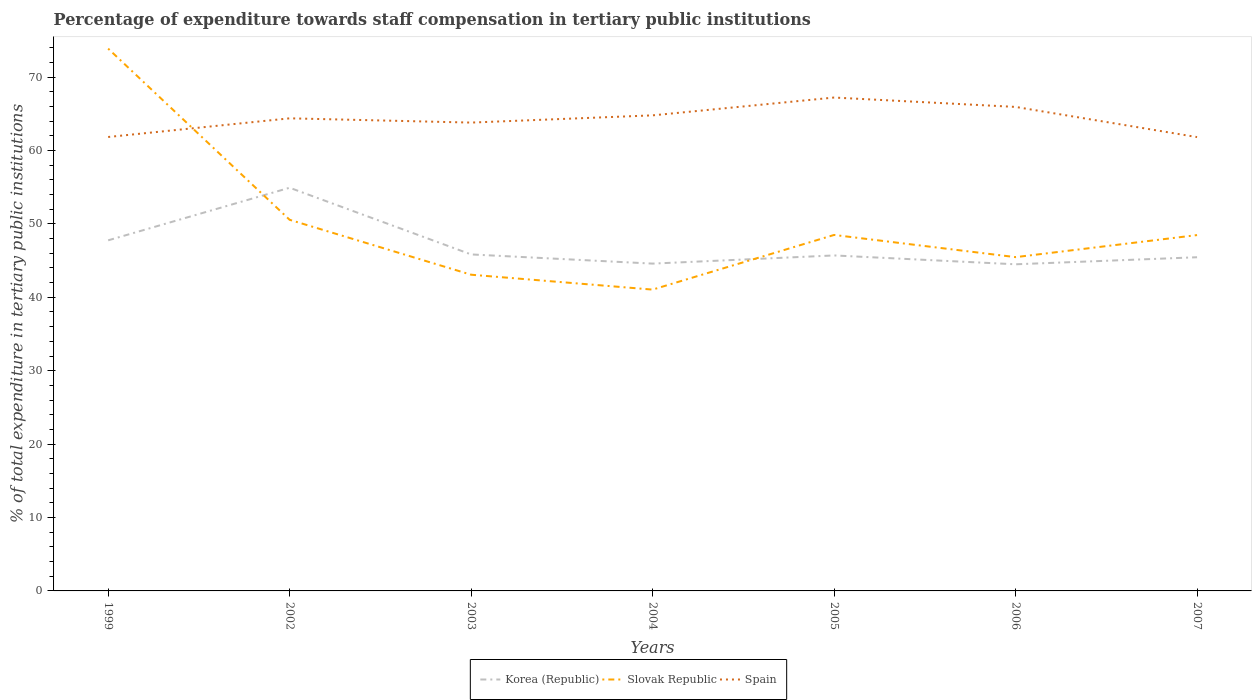How many different coloured lines are there?
Give a very brief answer. 3. Across all years, what is the maximum percentage of expenditure towards staff compensation in Korea (Republic)?
Your answer should be compact. 44.5. In which year was the percentage of expenditure towards staff compensation in Slovak Republic maximum?
Ensure brevity in your answer.  2004. What is the total percentage of expenditure towards staff compensation in Korea (Republic) in the graph?
Your answer should be compact. 10.34. What is the difference between the highest and the second highest percentage of expenditure towards staff compensation in Korea (Republic)?
Ensure brevity in your answer.  10.43. What is the difference between the highest and the lowest percentage of expenditure towards staff compensation in Spain?
Provide a short and direct response. 4. Is the percentage of expenditure towards staff compensation in Korea (Republic) strictly greater than the percentage of expenditure towards staff compensation in Slovak Republic over the years?
Offer a terse response. No. Does the graph contain any zero values?
Offer a very short reply. No. How are the legend labels stacked?
Provide a short and direct response. Horizontal. What is the title of the graph?
Your answer should be compact. Percentage of expenditure towards staff compensation in tertiary public institutions. Does "North America" appear as one of the legend labels in the graph?
Make the answer very short. No. What is the label or title of the X-axis?
Offer a very short reply. Years. What is the label or title of the Y-axis?
Your answer should be very brief. % of total expenditure in tertiary public institutions. What is the % of total expenditure in tertiary public institutions of Korea (Republic) in 1999?
Provide a succinct answer. 47.76. What is the % of total expenditure in tertiary public institutions of Slovak Republic in 1999?
Provide a succinct answer. 73.88. What is the % of total expenditure in tertiary public institutions in Spain in 1999?
Make the answer very short. 61.84. What is the % of total expenditure in tertiary public institutions in Korea (Republic) in 2002?
Your answer should be compact. 54.93. What is the % of total expenditure in tertiary public institutions in Slovak Republic in 2002?
Keep it short and to the point. 50.56. What is the % of total expenditure in tertiary public institutions in Spain in 2002?
Give a very brief answer. 64.38. What is the % of total expenditure in tertiary public institutions in Korea (Republic) in 2003?
Give a very brief answer. 45.84. What is the % of total expenditure in tertiary public institutions of Slovak Republic in 2003?
Your answer should be compact. 43.08. What is the % of total expenditure in tertiary public institutions of Spain in 2003?
Your answer should be very brief. 63.8. What is the % of total expenditure in tertiary public institutions of Korea (Republic) in 2004?
Your answer should be very brief. 44.59. What is the % of total expenditure in tertiary public institutions in Slovak Republic in 2004?
Your answer should be very brief. 41.05. What is the % of total expenditure in tertiary public institutions in Spain in 2004?
Your response must be concise. 64.79. What is the % of total expenditure in tertiary public institutions in Korea (Republic) in 2005?
Provide a succinct answer. 45.71. What is the % of total expenditure in tertiary public institutions in Slovak Republic in 2005?
Give a very brief answer. 48.5. What is the % of total expenditure in tertiary public institutions in Spain in 2005?
Offer a terse response. 67.22. What is the % of total expenditure in tertiary public institutions of Korea (Republic) in 2006?
Make the answer very short. 44.5. What is the % of total expenditure in tertiary public institutions of Slovak Republic in 2006?
Make the answer very short. 45.47. What is the % of total expenditure in tertiary public institutions in Spain in 2006?
Make the answer very short. 65.94. What is the % of total expenditure in tertiary public institutions of Korea (Republic) in 2007?
Offer a terse response. 45.46. What is the % of total expenditure in tertiary public institutions in Slovak Republic in 2007?
Your answer should be very brief. 48.48. What is the % of total expenditure in tertiary public institutions of Spain in 2007?
Offer a terse response. 61.83. Across all years, what is the maximum % of total expenditure in tertiary public institutions in Korea (Republic)?
Your response must be concise. 54.93. Across all years, what is the maximum % of total expenditure in tertiary public institutions of Slovak Republic?
Give a very brief answer. 73.88. Across all years, what is the maximum % of total expenditure in tertiary public institutions in Spain?
Provide a succinct answer. 67.22. Across all years, what is the minimum % of total expenditure in tertiary public institutions in Korea (Republic)?
Keep it short and to the point. 44.5. Across all years, what is the minimum % of total expenditure in tertiary public institutions of Slovak Republic?
Make the answer very short. 41.05. Across all years, what is the minimum % of total expenditure in tertiary public institutions in Spain?
Give a very brief answer. 61.83. What is the total % of total expenditure in tertiary public institutions of Korea (Republic) in the graph?
Your answer should be very brief. 328.79. What is the total % of total expenditure in tertiary public institutions in Slovak Republic in the graph?
Offer a terse response. 351.02. What is the total % of total expenditure in tertiary public institutions of Spain in the graph?
Your response must be concise. 449.8. What is the difference between the % of total expenditure in tertiary public institutions in Korea (Republic) in 1999 and that in 2002?
Provide a short and direct response. -7.16. What is the difference between the % of total expenditure in tertiary public institutions in Slovak Republic in 1999 and that in 2002?
Make the answer very short. 23.32. What is the difference between the % of total expenditure in tertiary public institutions of Spain in 1999 and that in 2002?
Keep it short and to the point. -2.54. What is the difference between the % of total expenditure in tertiary public institutions of Korea (Republic) in 1999 and that in 2003?
Your answer should be very brief. 1.92. What is the difference between the % of total expenditure in tertiary public institutions in Slovak Republic in 1999 and that in 2003?
Your answer should be compact. 30.8. What is the difference between the % of total expenditure in tertiary public institutions of Spain in 1999 and that in 2003?
Offer a very short reply. -1.96. What is the difference between the % of total expenditure in tertiary public institutions in Korea (Republic) in 1999 and that in 2004?
Provide a short and direct response. 3.17. What is the difference between the % of total expenditure in tertiary public institutions in Slovak Republic in 1999 and that in 2004?
Provide a succinct answer. 32.83. What is the difference between the % of total expenditure in tertiary public institutions in Spain in 1999 and that in 2004?
Your answer should be compact. -2.95. What is the difference between the % of total expenditure in tertiary public institutions of Korea (Republic) in 1999 and that in 2005?
Provide a short and direct response. 2.06. What is the difference between the % of total expenditure in tertiary public institutions of Slovak Republic in 1999 and that in 2005?
Make the answer very short. 25.39. What is the difference between the % of total expenditure in tertiary public institutions of Spain in 1999 and that in 2005?
Make the answer very short. -5.38. What is the difference between the % of total expenditure in tertiary public institutions in Korea (Republic) in 1999 and that in 2006?
Make the answer very short. 3.26. What is the difference between the % of total expenditure in tertiary public institutions of Slovak Republic in 1999 and that in 2006?
Provide a short and direct response. 28.41. What is the difference between the % of total expenditure in tertiary public institutions of Spain in 1999 and that in 2006?
Keep it short and to the point. -4.1. What is the difference between the % of total expenditure in tertiary public institutions in Korea (Republic) in 1999 and that in 2007?
Keep it short and to the point. 2.31. What is the difference between the % of total expenditure in tertiary public institutions of Slovak Republic in 1999 and that in 2007?
Ensure brevity in your answer.  25.4. What is the difference between the % of total expenditure in tertiary public institutions of Spain in 1999 and that in 2007?
Give a very brief answer. 0.01. What is the difference between the % of total expenditure in tertiary public institutions of Korea (Republic) in 2002 and that in 2003?
Your answer should be very brief. 9.09. What is the difference between the % of total expenditure in tertiary public institutions in Slovak Republic in 2002 and that in 2003?
Your response must be concise. 7.48. What is the difference between the % of total expenditure in tertiary public institutions of Spain in 2002 and that in 2003?
Provide a short and direct response. 0.58. What is the difference between the % of total expenditure in tertiary public institutions of Korea (Republic) in 2002 and that in 2004?
Ensure brevity in your answer.  10.34. What is the difference between the % of total expenditure in tertiary public institutions in Slovak Republic in 2002 and that in 2004?
Make the answer very short. 9.51. What is the difference between the % of total expenditure in tertiary public institutions of Spain in 2002 and that in 2004?
Keep it short and to the point. -0.41. What is the difference between the % of total expenditure in tertiary public institutions in Korea (Republic) in 2002 and that in 2005?
Provide a short and direct response. 9.22. What is the difference between the % of total expenditure in tertiary public institutions in Slovak Republic in 2002 and that in 2005?
Your answer should be very brief. 2.06. What is the difference between the % of total expenditure in tertiary public institutions of Spain in 2002 and that in 2005?
Offer a terse response. -2.83. What is the difference between the % of total expenditure in tertiary public institutions in Korea (Republic) in 2002 and that in 2006?
Offer a very short reply. 10.43. What is the difference between the % of total expenditure in tertiary public institutions in Slovak Republic in 2002 and that in 2006?
Provide a succinct answer. 5.09. What is the difference between the % of total expenditure in tertiary public institutions in Spain in 2002 and that in 2006?
Offer a terse response. -1.55. What is the difference between the % of total expenditure in tertiary public institutions in Korea (Republic) in 2002 and that in 2007?
Make the answer very short. 9.47. What is the difference between the % of total expenditure in tertiary public institutions of Slovak Republic in 2002 and that in 2007?
Your answer should be very brief. 2.08. What is the difference between the % of total expenditure in tertiary public institutions of Spain in 2002 and that in 2007?
Provide a succinct answer. 2.56. What is the difference between the % of total expenditure in tertiary public institutions of Korea (Republic) in 2003 and that in 2004?
Your answer should be compact. 1.25. What is the difference between the % of total expenditure in tertiary public institutions in Slovak Republic in 2003 and that in 2004?
Provide a short and direct response. 2.03. What is the difference between the % of total expenditure in tertiary public institutions of Spain in 2003 and that in 2004?
Your answer should be very brief. -0.98. What is the difference between the % of total expenditure in tertiary public institutions in Korea (Republic) in 2003 and that in 2005?
Your answer should be very brief. 0.14. What is the difference between the % of total expenditure in tertiary public institutions of Slovak Republic in 2003 and that in 2005?
Ensure brevity in your answer.  -5.42. What is the difference between the % of total expenditure in tertiary public institutions in Spain in 2003 and that in 2005?
Ensure brevity in your answer.  -3.41. What is the difference between the % of total expenditure in tertiary public institutions of Korea (Republic) in 2003 and that in 2006?
Offer a very short reply. 1.34. What is the difference between the % of total expenditure in tertiary public institutions of Slovak Republic in 2003 and that in 2006?
Your response must be concise. -2.4. What is the difference between the % of total expenditure in tertiary public institutions in Spain in 2003 and that in 2006?
Your answer should be very brief. -2.13. What is the difference between the % of total expenditure in tertiary public institutions of Korea (Republic) in 2003 and that in 2007?
Keep it short and to the point. 0.38. What is the difference between the % of total expenditure in tertiary public institutions of Slovak Republic in 2003 and that in 2007?
Offer a very short reply. -5.4. What is the difference between the % of total expenditure in tertiary public institutions of Spain in 2003 and that in 2007?
Provide a short and direct response. 1.98. What is the difference between the % of total expenditure in tertiary public institutions of Korea (Republic) in 2004 and that in 2005?
Give a very brief answer. -1.11. What is the difference between the % of total expenditure in tertiary public institutions in Slovak Republic in 2004 and that in 2005?
Offer a very short reply. -7.45. What is the difference between the % of total expenditure in tertiary public institutions in Spain in 2004 and that in 2005?
Your answer should be compact. -2.43. What is the difference between the % of total expenditure in tertiary public institutions of Korea (Republic) in 2004 and that in 2006?
Offer a very short reply. 0.09. What is the difference between the % of total expenditure in tertiary public institutions of Slovak Republic in 2004 and that in 2006?
Provide a succinct answer. -4.42. What is the difference between the % of total expenditure in tertiary public institutions of Spain in 2004 and that in 2006?
Your answer should be very brief. -1.15. What is the difference between the % of total expenditure in tertiary public institutions of Korea (Republic) in 2004 and that in 2007?
Offer a terse response. -0.87. What is the difference between the % of total expenditure in tertiary public institutions in Slovak Republic in 2004 and that in 2007?
Offer a very short reply. -7.43. What is the difference between the % of total expenditure in tertiary public institutions in Spain in 2004 and that in 2007?
Give a very brief answer. 2.96. What is the difference between the % of total expenditure in tertiary public institutions of Korea (Republic) in 2005 and that in 2006?
Keep it short and to the point. 1.21. What is the difference between the % of total expenditure in tertiary public institutions in Slovak Republic in 2005 and that in 2006?
Your response must be concise. 3.02. What is the difference between the % of total expenditure in tertiary public institutions in Spain in 2005 and that in 2006?
Offer a terse response. 1.28. What is the difference between the % of total expenditure in tertiary public institutions in Korea (Republic) in 2005 and that in 2007?
Offer a terse response. 0.25. What is the difference between the % of total expenditure in tertiary public institutions in Slovak Republic in 2005 and that in 2007?
Give a very brief answer. 0.02. What is the difference between the % of total expenditure in tertiary public institutions in Spain in 2005 and that in 2007?
Give a very brief answer. 5.39. What is the difference between the % of total expenditure in tertiary public institutions in Korea (Republic) in 2006 and that in 2007?
Offer a terse response. -0.96. What is the difference between the % of total expenditure in tertiary public institutions of Slovak Republic in 2006 and that in 2007?
Your answer should be very brief. -3. What is the difference between the % of total expenditure in tertiary public institutions of Spain in 2006 and that in 2007?
Your response must be concise. 4.11. What is the difference between the % of total expenditure in tertiary public institutions in Korea (Republic) in 1999 and the % of total expenditure in tertiary public institutions in Slovak Republic in 2002?
Your answer should be very brief. -2.8. What is the difference between the % of total expenditure in tertiary public institutions of Korea (Republic) in 1999 and the % of total expenditure in tertiary public institutions of Spain in 2002?
Make the answer very short. -16.62. What is the difference between the % of total expenditure in tertiary public institutions in Slovak Republic in 1999 and the % of total expenditure in tertiary public institutions in Spain in 2002?
Your answer should be very brief. 9.5. What is the difference between the % of total expenditure in tertiary public institutions in Korea (Republic) in 1999 and the % of total expenditure in tertiary public institutions in Slovak Republic in 2003?
Give a very brief answer. 4.69. What is the difference between the % of total expenditure in tertiary public institutions of Korea (Republic) in 1999 and the % of total expenditure in tertiary public institutions of Spain in 2003?
Your answer should be compact. -16.04. What is the difference between the % of total expenditure in tertiary public institutions of Slovak Republic in 1999 and the % of total expenditure in tertiary public institutions of Spain in 2003?
Your answer should be compact. 10.08. What is the difference between the % of total expenditure in tertiary public institutions in Korea (Republic) in 1999 and the % of total expenditure in tertiary public institutions in Slovak Republic in 2004?
Your answer should be compact. 6.71. What is the difference between the % of total expenditure in tertiary public institutions in Korea (Republic) in 1999 and the % of total expenditure in tertiary public institutions in Spain in 2004?
Keep it short and to the point. -17.03. What is the difference between the % of total expenditure in tertiary public institutions in Slovak Republic in 1999 and the % of total expenditure in tertiary public institutions in Spain in 2004?
Offer a terse response. 9.09. What is the difference between the % of total expenditure in tertiary public institutions of Korea (Republic) in 1999 and the % of total expenditure in tertiary public institutions of Slovak Republic in 2005?
Provide a succinct answer. -0.73. What is the difference between the % of total expenditure in tertiary public institutions of Korea (Republic) in 1999 and the % of total expenditure in tertiary public institutions of Spain in 2005?
Give a very brief answer. -19.45. What is the difference between the % of total expenditure in tertiary public institutions in Slovak Republic in 1999 and the % of total expenditure in tertiary public institutions in Spain in 2005?
Provide a short and direct response. 6.66. What is the difference between the % of total expenditure in tertiary public institutions of Korea (Republic) in 1999 and the % of total expenditure in tertiary public institutions of Slovak Republic in 2006?
Your answer should be compact. 2.29. What is the difference between the % of total expenditure in tertiary public institutions in Korea (Republic) in 1999 and the % of total expenditure in tertiary public institutions in Spain in 2006?
Make the answer very short. -18.17. What is the difference between the % of total expenditure in tertiary public institutions in Slovak Republic in 1999 and the % of total expenditure in tertiary public institutions in Spain in 2006?
Your answer should be very brief. 7.94. What is the difference between the % of total expenditure in tertiary public institutions of Korea (Republic) in 1999 and the % of total expenditure in tertiary public institutions of Slovak Republic in 2007?
Provide a short and direct response. -0.71. What is the difference between the % of total expenditure in tertiary public institutions of Korea (Republic) in 1999 and the % of total expenditure in tertiary public institutions of Spain in 2007?
Your response must be concise. -14.06. What is the difference between the % of total expenditure in tertiary public institutions in Slovak Republic in 1999 and the % of total expenditure in tertiary public institutions in Spain in 2007?
Make the answer very short. 12.05. What is the difference between the % of total expenditure in tertiary public institutions in Korea (Republic) in 2002 and the % of total expenditure in tertiary public institutions in Slovak Republic in 2003?
Give a very brief answer. 11.85. What is the difference between the % of total expenditure in tertiary public institutions of Korea (Republic) in 2002 and the % of total expenditure in tertiary public institutions of Spain in 2003?
Your answer should be compact. -8.88. What is the difference between the % of total expenditure in tertiary public institutions of Slovak Republic in 2002 and the % of total expenditure in tertiary public institutions of Spain in 2003?
Ensure brevity in your answer.  -13.24. What is the difference between the % of total expenditure in tertiary public institutions of Korea (Republic) in 2002 and the % of total expenditure in tertiary public institutions of Slovak Republic in 2004?
Provide a succinct answer. 13.88. What is the difference between the % of total expenditure in tertiary public institutions in Korea (Republic) in 2002 and the % of total expenditure in tertiary public institutions in Spain in 2004?
Ensure brevity in your answer.  -9.86. What is the difference between the % of total expenditure in tertiary public institutions of Slovak Republic in 2002 and the % of total expenditure in tertiary public institutions of Spain in 2004?
Your response must be concise. -14.23. What is the difference between the % of total expenditure in tertiary public institutions in Korea (Republic) in 2002 and the % of total expenditure in tertiary public institutions in Slovak Republic in 2005?
Offer a very short reply. 6.43. What is the difference between the % of total expenditure in tertiary public institutions in Korea (Republic) in 2002 and the % of total expenditure in tertiary public institutions in Spain in 2005?
Keep it short and to the point. -12.29. What is the difference between the % of total expenditure in tertiary public institutions of Slovak Republic in 2002 and the % of total expenditure in tertiary public institutions of Spain in 2005?
Provide a short and direct response. -16.66. What is the difference between the % of total expenditure in tertiary public institutions of Korea (Republic) in 2002 and the % of total expenditure in tertiary public institutions of Slovak Republic in 2006?
Provide a short and direct response. 9.45. What is the difference between the % of total expenditure in tertiary public institutions in Korea (Republic) in 2002 and the % of total expenditure in tertiary public institutions in Spain in 2006?
Make the answer very short. -11.01. What is the difference between the % of total expenditure in tertiary public institutions in Slovak Republic in 2002 and the % of total expenditure in tertiary public institutions in Spain in 2006?
Make the answer very short. -15.38. What is the difference between the % of total expenditure in tertiary public institutions in Korea (Republic) in 2002 and the % of total expenditure in tertiary public institutions in Slovak Republic in 2007?
Your answer should be very brief. 6.45. What is the difference between the % of total expenditure in tertiary public institutions in Korea (Republic) in 2002 and the % of total expenditure in tertiary public institutions in Spain in 2007?
Provide a succinct answer. -6.9. What is the difference between the % of total expenditure in tertiary public institutions of Slovak Republic in 2002 and the % of total expenditure in tertiary public institutions of Spain in 2007?
Your answer should be compact. -11.27. What is the difference between the % of total expenditure in tertiary public institutions of Korea (Republic) in 2003 and the % of total expenditure in tertiary public institutions of Slovak Republic in 2004?
Ensure brevity in your answer.  4.79. What is the difference between the % of total expenditure in tertiary public institutions of Korea (Republic) in 2003 and the % of total expenditure in tertiary public institutions of Spain in 2004?
Offer a very short reply. -18.95. What is the difference between the % of total expenditure in tertiary public institutions in Slovak Republic in 2003 and the % of total expenditure in tertiary public institutions in Spain in 2004?
Your answer should be very brief. -21.71. What is the difference between the % of total expenditure in tertiary public institutions in Korea (Republic) in 2003 and the % of total expenditure in tertiary public institutions in Slovak Republic in 2005?
Offer a very short reply. -2.65. What is the difference between the % of total expenditure in tertiary public institutions of Korea (Republic) in 2003 and the % of total expenditure in tertiary public institutions of Spain in 2005?
Ensure brevity in your answer.  -21.37. What is the difference between the % of total expenditure in tertiary public institutions of Slovak Republic in 2003 and the % of total expenditure in tertiary public institutions of Spain in 2005?
Make the answer very short. -24.14. What is the difference between the % of total expenditure in tertiary public institutions in Korea (Republic) in 2003 and the % of total expenditure in tertiary public institutions in Slovak Republic in 2006?
Provide a succinct answer. 0.37. What is the difference between the % of total expenditure in tertiary public institutions of Korea (Republic) in 2003 and the % of total expenditure in tertiary public institutions of Spain in 2006?
Offer a very short reply. -20.1. What is the difference between the % of total expenditure in tertiary public institutions of Slovak Republic in 2003 and the % of total expenditure in tertiary public institutions of Spain in 2006?
Offer a terse response. -22.86. What is the difference between the % of total expenditure in tertiary public institutions of Korea (Republic) in 2003 and the % of total expenditure in tertiary public institutions of Slovak Republic in 2007?
Give a very brief answer. -2.63. What is the difference between the % of total expenditure in tertiary public institutions of Korea (Republic) in 2003 and the % of total expenditure in tertiary public institutions of Spain in 2007?
Keep it short and to the point. -15.99. What is the difference between the % of total expenditure in tertiary public institutions of Slovak Republic in 2003 and the % of total expenditure in tertiary public institutions of Spain in 2007?
Keep it short and to the point. -18.75. What is the difference between the % of total expenditure in tertiary public institutions in Korea (Republic) in 2004 and the % of total expenditure in tertiary public institutions in Slovak Republic in 2005?
Offer a terse response. -3.9. What is the difference between the % of total expenditure in tertiary public institutions of Korea (Republic) in 2004 and the % of total expenditure in tertiary public institutions of Spain in 2005?
Keep it short and to the point. -22.63. What is the difference between the % of total expenditure in tertiary public institutions in Slovak Republic in 2004 and the % of total expenditure in tertiary public institutions in Spain in 2005?
Your answer should be compact. -26.17. What is the difference between the % of total expenditure in tertiary public institutions in Korea (Republic) in 2004 and the % of total expenditure in tertiary public institutions in Slovak Republic in 2006?
Keep it short and to the point. -0.88. What is the difference between the % of total expenditure in tertiary public institutions in Korea (Republic) in 2004 and the % of total expenditure in tertiary public institutions in Spain in 2006?
Ensure brevity in your answer.  -21.35. What is the difference between the % of total expenditure in tertiary public institutions in Slovak Republic in 2004 and the % of total expenditure in tertiary public institutions in Spain in 2006?
Offer a very short reply. -24.89. What is the difference between the % of total expenditure in tertiary public institutions of Korea (Republic) in 2004 and the % of total expenditure in tertiary public institutions of Slovak Republic in 2007?
Your response must be concise. -3.89. What is the difference between the % of total expenditure in tertiary public institutions of Korea (Republic) in 2004 and the % of total expenditure in tertiary public institutions of Spain in 2007?
Your answer should be compact. -17.24. What is the difference between the % of total expenditure in tertiary public institutions of Slovak Republic in 2004 and the % of total expenditure in tertiary public institutions of Spain in 2007?
Keep it short and to the point. -20.78. What is the difference between the % of total expenditure in tertiary public institutions in Korea (Republic) in 2005 and the % of total expenditure in tertiary public institutions in Slovak Republic in 2006?
Offer a terse response. 0.23. What is the difference between the % of total expenditure in tertiary public institutions of Korea (Republic) in 2005 and the % of total expenditure in tertiary public institutions of Spain in 2006?
Your response must be concise. -20.23. What is the difference between the % of total expenditure in tertiary public institutions of Slovak Republic in 2005 and the % of total expenditure in tertiary public institutions of Spain in 2006?
Give a very brief answer. -17.44. What is the difference between the % of total expenditure in tertiary public institutions in Korea (Republic) in 2005 and the % of total expenditure in tertiary public institutions in Slovak Republic in 2007?
Ensure brevity in your answer.  -2.77. What is the difference between the % of total expenditure in tertiary public institutions of Korea (Republic) in 2005 and the % of total expenditure in tertiary public institutions of Spain in 2007?
Offer a terse response. -16.12. What is the difference between the % of total expenditure in tertiary public institutions in Slovak Republic in 2005 and the % of total expenditure in tertiary public institutions in Spain in 2007?
Ensure brevity in your answer.  -13.33. What is the difference between the % of total expenditure in tertiary public institutions of Korea (Republic) in 2006 and the % of total expenditure in tertiary public institutions of Slovak Republic in 2007?
Provide a short and direct response. -3.98. What is the difference between the % of total expenditure in tertiary public institutions of Korea (Republic) in 2006 and the % of total expenditure in tertiary public institutions of Spain in 2007?
Give a very brief answer. -17.33. What is the difference between the % of total expenditure in tertiary public institutions in Slovak Republic in 2006 and the % of total expenditure in tertiary public institutions in Spain in 2007?
Give a very brief answer. -16.35. What is the average % of total expenditure in tertiary public institutions in Korea (Republic) per year?
Provide a short and direct response. 46.97. What is the average % of total expenditure in tertiary public institutions of Slovak Republic per year?
Provide a short and direct response. 50.15. What is the average % of total expenditure in tertiary public institutions of Spain per year?
Your response must be concise. 64.26. In the year 1999, what is the difference between the % of total expenditure in tertiary public institutions of Korea (Republic) and % of total expenditure in tertiary public institutions of Slovak Republic?
Offer a very short reply. -26.12. In the year 1999, what is the difference between the % of total expenditure in tertiary public institutions in Korea (Republic) and % of total expenditure in tertiary public institutions in Spain?
Your answer should be compact. -14.08. In the year 1999, what is the difference between the % of total expenditure in tertiary public institutions in Slovak Republic and % of total expenditure in tertiary public institutions in Spain?
Give a very brief answer. 12.04. In the year 2002, what is the difference between the % of total expenditure in tertiary public institutions in Korea (Republic) and % of total expenditure in tertiary public institutions in Slovak Republic?
Give a very brief answer. 4.37. In the year 2002, what is the difference between the % of total expenditure in tertiary public institutions of Korea (Republic) and % of total expenditure in tertiary public institutions of Spain?
Provide a short and direct response. -9.46. In the year 2002, what is the difference between the % of total expenditure in tertiary public institutions in Slovak Republic and % of total expenditure in tertiary public institutions in Spain?
Keep it short and to the point. -13.82. In the year 2003, what is the difference between the % of total expenditure in tertiary public institutions in Korea (Republic) and % of total expenditure in tertiary public institutions in Slovak Republic?
Make the answer very short. 2.76. In the year 2003, what is the difference between the % of total expenditure in tertiary public institutions in Korea (Republic) and % of total expenditure in tertiary public institutions in Spain?
Your answer should be compact. -17.96. In the year 2003, what is the difference between the % of total expenditure in tertiary public institutions of Slovak Republic and % of total expenditure in tertiary public institutions of Spain?
Offer a very short reply. -20.73. In the year 2004, what is the difference between the % of total expenditure in tertiary public institutions in Korea (Republic) and % of total expenditure in tertiary public institutions in Slovak Republic?
Ensure brevity in your answer.  3.54. In the year 2004, what is the difference between the % of total expenditure in tertiary public institutions of Korea (Republic) and % of total expenditure in tertiary public institutions of Spain?
Offer a very short reply. -20.2. In the year 2004, what is the difference between the % of total expenditure in tertiary public institutions in Slovak Republic and % of total expenditure in tertiary public institutions in Spain?
Your response must be concise. -23.74. In the year 2005, what is the difference between the % of total expenditure in tertiary public institutions in Korea (Republic) and % of total expenditure in tertiary public institutions in Slovak Republic?
Your answer should be very brief. -2.79. In the year 2005, what is the difference between the % of total expenditure in tertiary public institutions in Korea (Republic) and % of total expenditure in tertiary public institutions in Spain?
Your answer should be compact. -21.51. In the year 2005, what is the difference between the % of total expenditure in tertiary public institutions of Slovak Republic and % of total expenditure in tertiary public institutions of Spain?
Your answer should be compact. -18.72. In the year 2006, what is the difference between the % of total expenditure in tertiary public institutions in Korea (Republic) and % of total expenditure in tertiary public institutions in Slovak Republic?
Your answer should be compact. -0.97. In the year 2006, what is the difference between the % of total expenditure in tertiary public institutions of Korea (Republic) and % of total expenditure in tertiary public institutions of Spain?
Make the answer very short. -21.44. In the year 2006, what is the difference between the % of total expenditure in tertiary public institutions of Slovak Republic and % of total expenditure in tertiary public institutions of Spain?
Make the answer very short. -20.46. In the year 2007, what is the difference between the % of total expenditure in tertiary public institutions in Korea (Republic) and % of total expenditure in tertiary public institutions in Slovak Republic?
Your response must be concise. -3.02. In the year 2007, what is the difference between the % of total expenditure in tertiary public institutions of Korea (Republic) and % of total expenditure in tertiary public institutions of Spain?
Provide a short and direct response. -16.37. In the year 2007, what is the difference between the % of total expenditure in tertiary public institutions in Slovak Republic and % of total expenditure in tertiary public institutions in Spain?
Provide a short and direct response. -13.35. What is the ratio of the % of total expenditure in tertiary public institutions in Korea (Republic) in 1999 to that in 2002?
Ensure brevity in your answer.  0.87. What is the ratio of the % of total expenditure in tertiary public institutions in Slovak Republic in 1999 to that in 2002?
Your answer should be very brief. 1.46. What is the ratio of the % of total expenditure in tertiary public institutions of Spain in 1999 to that in 2002?
Offer a terse response. 0.96. What is the ratio of the % of total expenditure in tertiary public institutions of Korea (Republic) in 1999 to that in 2003?
Your answer should be compact. 1.04. What is the ratio of the % of total expenditure in tertiary public institutions in Slovak Republic in 1999 to that in 2003?
Offer a terse response. 1.72. What is the ratio of the % of total expenditure in tertiary public institutions in Spain in 1999 to that in 2003?
Make the answer very short. 0.97. What is the ratio of the % of total expenditure in tertiary public institutions in Korea (Republic) in 1999 to that in 2004?
Give a very brief answer. 1.07. What is the ratio of the % of total expenditure in tertiary public institutions of Slovak Republic in 1999 to that in 2004?
Your response must be concise. 1.8. What is the ratio of the % of total expenditure in tertiary public institutions in Spain in 1999 to that in 2004?
Your answer should be very brief. 0.95. What is the ratio of the % of total expenditure in tertiary public institutions of Korea (Republic) in 1999 to that in 2005?
Keep it short and to the point. 1.04. What is the ratio of the % of total expenditure in tertiary public institutions of Slovak Republic in 1999 to that in 2005?
Provide a short and direct response. 1.52. What is the ratio of the % of total expenditure in tertiary public institutions in Korea (Republic) in 1999 to that in 2006?
Give a very brief answer. 1.07. What is the ratio of the % of total expenditure in tertiary public institutions of Slovak Republic in 1999 to that in 2006?
Your answer should be very brief. 1.62. What is the ratio of the % of total expenditure in tertiary public institutions of Spain in 1999 to that in 2006?
Your answer should be very brief. 0.94. What is the ratio of the % of total expenditure in tertiary public institutions in Korea (Republic) in 1999 to that in 2007?
Your answer should be very brief. 1.05. What is the ratio of the % of total expenditure in tertiary public institutions in Slovak Republic in 1999 to that in 2007?
Your response must be concise. 1.52. What is the ratio of the % of total expenditure in tertiary public institutions in Spain in 1999 to that in 2007?
Offer a very short reply. 1. What is the ratio of the % of total expenditure in tertiary public institutions of Korea (Republic) in 2002 to that in 2003?
Your response must be concise. 1.2. What is the ratio of the % of total expenditure in tertiary public institutions of Slovak Republic in 2002 to that in 2003?
Make the answer very short. 1.17. What is the ratio of the % of total expenditure in tertiary public institutions in Spain in 2002 to that in 2003?
Your answer should be very brief. 1.01. What is the ratio of the % of total expenditure in tertiary public institutions in Korea (Republic) in 2002 to that in 2004?
Offer a very short reply. 1.23. What is the ratio of the % of total expenditure in tertiary public institutions in Slovak Republic in 2002 to that in 2004?
Your answer should be very brief. 1.23. What is the ratio of the % of total expenditure in tertiary public institutions of Korea (Republic) in 2002 to that in 2005?
Keep it short and to the point. 1.2. What is the ratio of the % of total expenditure in tertiary public institutions in Slovak Republic in 2002 to that in 2005?
Your answer should be very brief. 1.04. What is the ratio of the % of total expenditure in tertiary public institutions in Spain in 2002 to that in 2005?
Your answer should be compact. 0.96. What is the ratio of the % of total expenditure in tertiary public institutions in Korea (Republic) in 2002 to that in 2006?
Offer a terse response. 1.23. What is the ratio of the % of total expenditure in tertiary public institutions of Slovak Republic in 2002 to that in 2006?
Make the answer very short. 1.11. What is the ratio of the % of total expenditure in tertiary public institutions in Spain in 2002 to that in 2006?
Your answer should be compact. 0.98. What is the ratio of the % of total expenditure in tertiary public institutions of Korea (Republic) in 2002 to that in 2007?
Make the answer very short. 1.21. What is the ratio of the % of total expenditure in tertiary public institutions of Slovak Republic in 2002 to that in 2007?
Offer a terse response. 1.04. What is the ratio of the % of total expenditure in tertiary public institutions of Spain in 2002 to that in 2007?
Your response must be concise. 1.04. What is the ratio of the % of total expenditure in tertiary public institutions of Korea (Republic) in 2003 to that in 2004?
Provide a short and direct response. 1.03. What is the ratio of the % of total expenditure in tertiary public institutions in Slovak Republic in 2003 to that in 2004?
Give a very brief answer. 1.05. What is the ratio of the % of total expenditure in tertiary public institutions of Korea (Republic) in 2003 to that in 2005?
Offer a very short reply. 1. What is the ratio of the % of total expenditure in tertiary public institutions of Slovak Republic in 2003 to that in 2005?
Provide a short and direct response. 0.89. What is the ratio of the % of total expenditure in tertiary public institutions of Spain in 2003 to that in 2005?
Keep it short and to the point. 0.95. What is the ratio of the % of total expenditure in tertiary public institutions of Korea (Republic) in 2003 to that in 2006?
Make the answer very short. 1.03. What is the ratio of the % of total expenditure in tertiary public institutions in Slovak Republic in 2003 to that in 2006?
Offer a terse response. 0.95. What is the ratio of the % of total expenditure in tertiary public institutions in Spain in 2003 to that in 2006?
Offer a very short reply. 0.97. What is the ratio of the % of total expenditure in tertiary public institutions of Korea (Republic) in 2003 to that in 2007?
Make the answer very short. 1.01. What is the ratio of the % of total expenditure in tertiary public institutions in Slovak Republic in 2003 to that in 2007?
Give a very brief answer. 0.89. What is the ratio of the % of total expenditure in tertiary public institutions of Spain in 2003 to that in 2007?
Your response must be concise. 1.03. What is the ratio of the % of total expenditure in tertiary public institutions in Korea (Republic) in 2004 to that in 2005?
Your answer should be very brief. 0.98. What is the ratio of the % of total expenditure in tertiary public institutions of Slovak Republic in 2004 to that in 2005?
Make the answer very short. 0.85. What is the ratio of the % of total expenditure in tertiary public institutions of Spain in 2004 to that in 2005?
Keep it short and to the point. 0.96. What is the ratio of the % of total expenditure in tertiary public institutions in Korea (Republic) in 2004 to that in 2006?
Your answer should be compact. 1. What is the ratio of the % of total expenditure in tertiary public institutions of Slovak Republic in 2004 to that in 2006?
Your answer should be compact. 0.9. What is the ratio of the % of total expenditure in tertiary public institutions of Spain in 2004 to that in 2006?
Offer a very short reply. 0.98. What is the ratio of the % of total expenditure in tertiary public institutions in Korea (Republic) in 2004 to that in 2007?
Your response must be concise. 0.98. What is the ratio of the % of total expenditure in tertiary public institutions of Slovak Republic in 2004 to that in 2007?
Ensure brevity in your answer.  0.85. What is the ratio of the % of total expenditure in tertiary public institutions of Spain in 2004 to that in 2007?
Your response must be concise. 1.05. What is the ratio of the % of total expenditure in tertiary public institutions of Korea (Republic) in 2005 to that in 2006?
Make the answer very short. 1.03. What is the ratio of the % of total expenditure in tertiary public institutions in Slovak Republic in 2005 to that in 2006?
Your answer should be compact. 1.07. What is the ratio of the % of total expenditure in tertiary public institutions of Spain in 2005 to that in 2006?
Your answer should be very brief. 1.02. What is the ratio of the % of total expenditure in tertiary public institutions of Korea (Republic) in 2005 to that in 2007?
Keep it short and to the point. 1.01. What is the ratio of the % of total expenditure in tertiary public institutions of Slovak Republic in 2005 to that in 2007?
Your answer should be compact. 1. What is the ratio of the % of total expenditure in tertiary public institutions of Spain in 2005 to that in 2007?
Provide a short and direct response. 1.09. What is the ratio of the % of total expenditure in tertiary public institutions in Korea (Republic) in 2006 to that in 2007?
Your response must be concise. 0.98. What is the ratio of the % of total expenditure in tertiary public institutions of Slovak Republic in 2006 to that in 2007?
Offer a terse response. 0.94. What is the ratio of the % of total expenditure in tertiary public institutions in Spain in 2006 to that in 2007?
Offer a terse response. 1.07. What is the difference between the highest and the second highest % of total expenditure in tertiary public institutions of Korea (Republic)?
Your answer should be very brief. 7.16. What is the difference between the highest and the second highest % of total expenditure in tertiary public institutions in Slovak Republic?
Your answer should be very brief. 23.32. What is the difference between the highest and the second highest % of total expenditure in tertiary public institutions of Spain?
Ensure brevity in your answer.  1.28. What is the difference between the highest and the lowest % of total expenditure in tertiary public institutions in Korea (Republic)?
Ensure brevity in your answer.  10.43. What is the difference between the highest and the lowest % of total expenditure in tertiary public institutions of Slovak Republic?
Provide a short and direct response. 32.83. What is the difference between the highest and the lowest % of total expenditure in tertiary public institutions in Spain?
Ensure brevity in your answer.  5.39. 